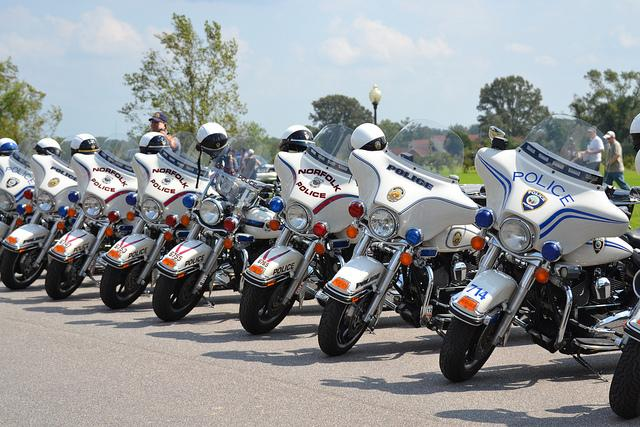What is beneath the number 714? light 